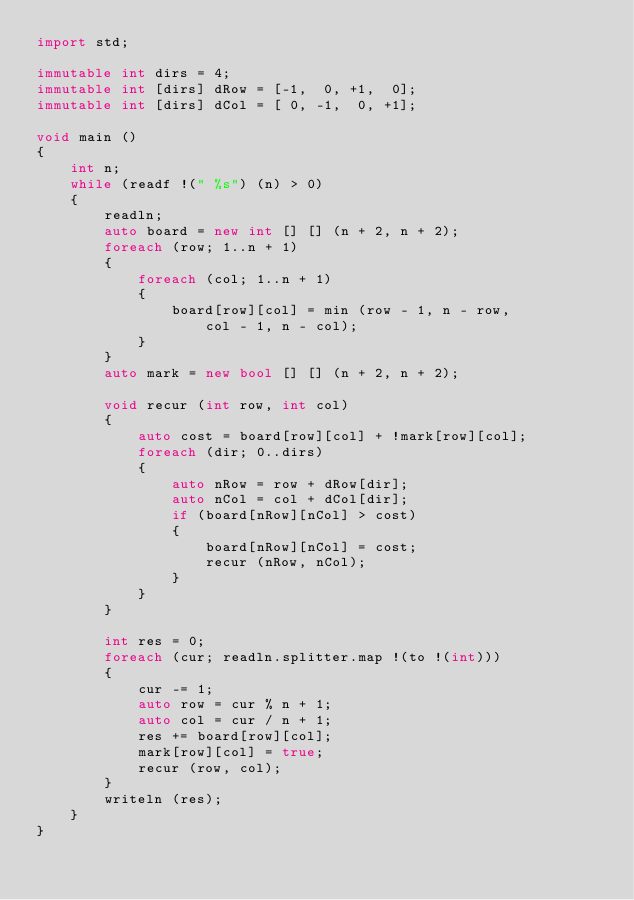Convert code to text. <code><loc_0><loc_0><loc_500><loc_500><_D_>import std;

immutable int dirs = 4;
immutable int [dirs] dRow = [-1,  0, +1,  0];
immutable int [dirs] dCol = [ 0, -1,  0, +1];

void main ()
{
	int n;
	while (readf !(" %s") (n) > 0)
	{
		readln;
		auto board = new int [] [] (n + 2, n + 2);
		foreach (row; 1..n + 1)
		{
			foreach (col; 1..n + 1)
			{
				board[row][col] = min (row - 1, n - row,
				    col - 1, n - col);
			}
		}
		auto mark = new bool [] [] (n + 2, n + 2);

		void recur (int row, int col)
		{
			auto cost = board[row][col] + !mark[row][col];
			foreach (dir; 0..dirs)
			{
				auto nRow = row + dRow[dir];
				auto nCol = col + dCol[dir];
				if (board[nRow][nCol] > cost)
				{
					board[nRow][nCol] = cost;
					recur (nRow, nCol);
				}
			}
		}

		int res = 0;
		foreach (cur; readln.splitter.map !(to !(int)))
		{
			cur -= 1;
			auto row = cur % n + 1;
			auto col = cur / n + 1;
			res += board[row][col];
			mark[row][col] = true;
			recur (row, col);
		}
		writeln (res);
	}
}
</code> 